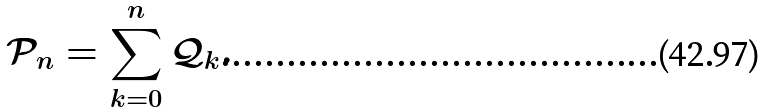<formula> <loc_0><loc_0><loc_500><loc_500>\mathcal { P } _ { n } = \sum _ { k = 0 } ^ { n } \mathcal { Q } _ { k } .</formula> 